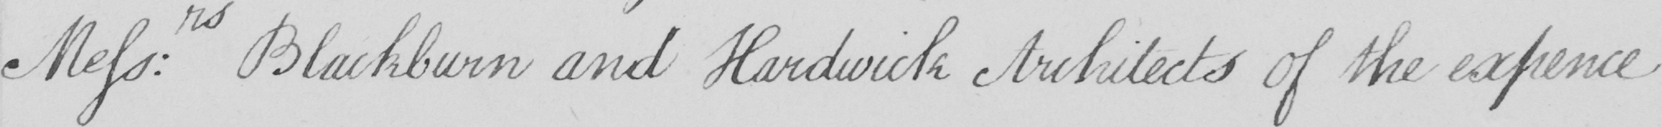Can you tell me what this handwritten text says? Mess : rs Blackburn and Hardwick Architects of the expence 